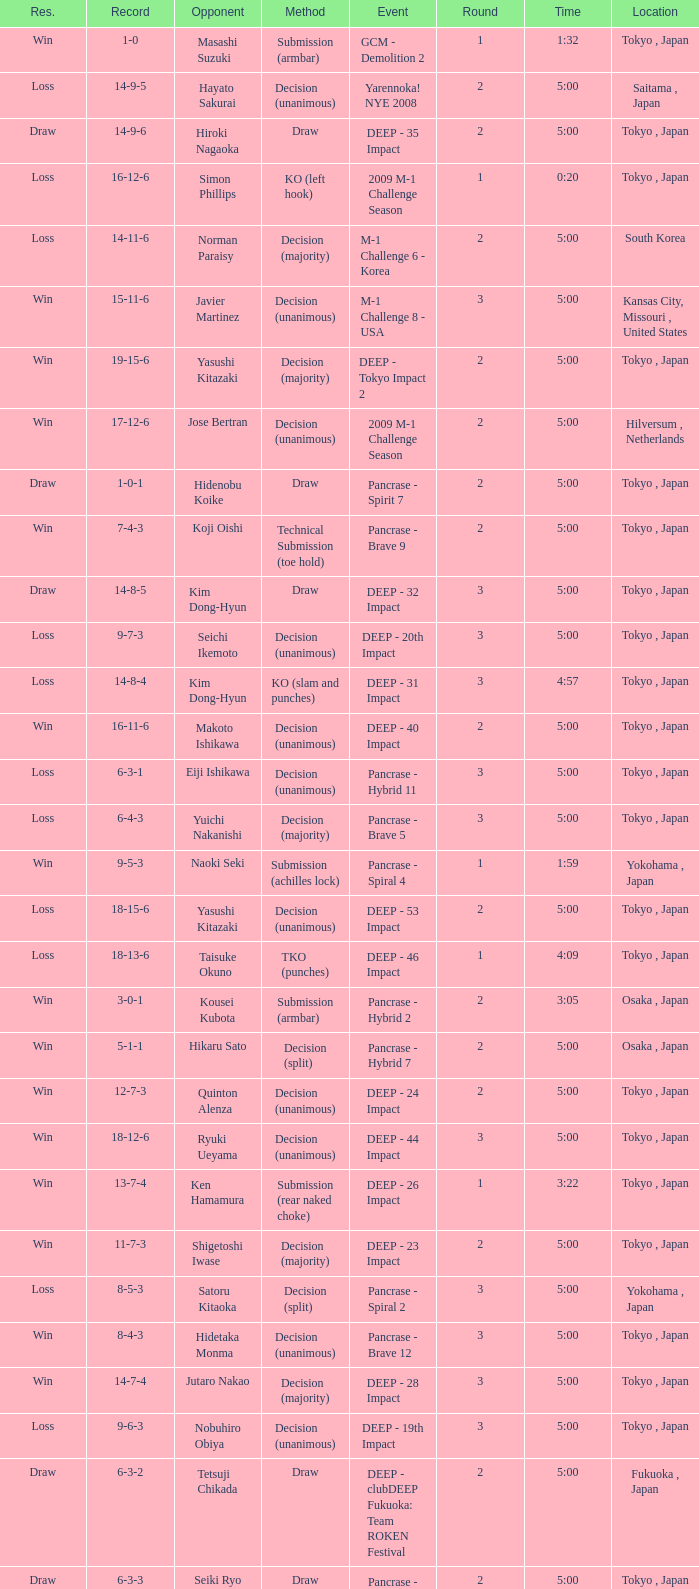What is the location when the record is 5-1-1? Osaka , Japan. 